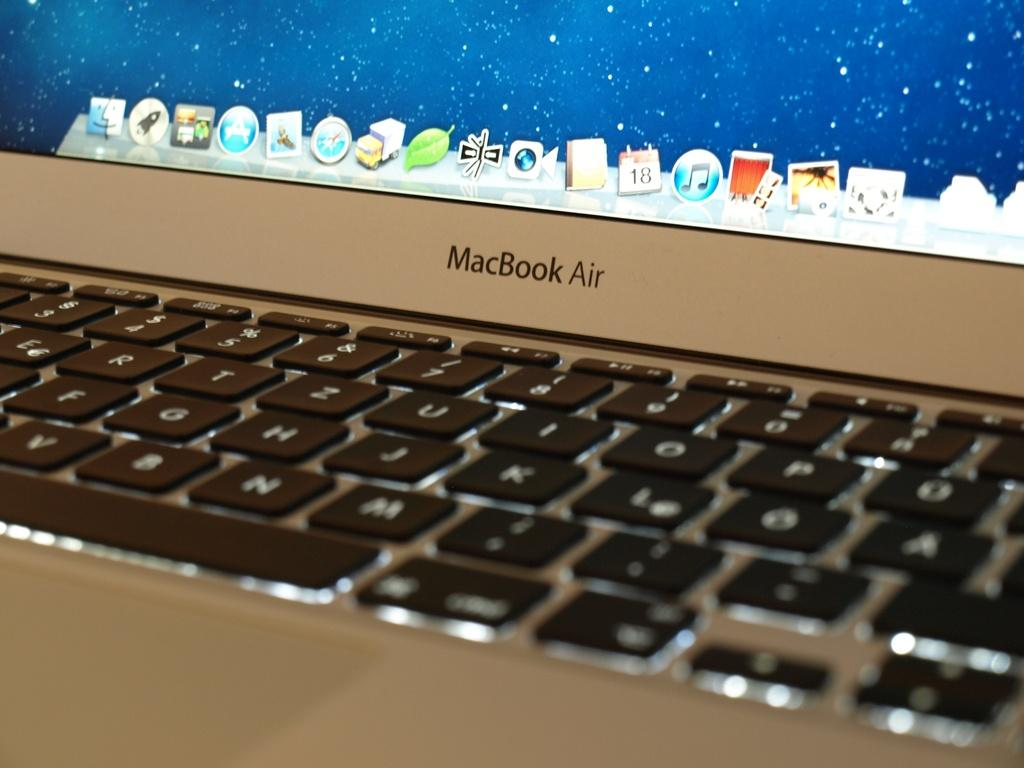What type of device is visible in the image? There is a keyboard in the image. What is the purpose of the keyboard? The keyboard is used for inputting data or commands into a computer or other electronic device. What else can be seen in the image besides the keyboard? There is a monitor screen in the image. What is the primary function of the monitor screen? The monitor screen is used for displaying information, images, or videos from a computer or other electronic device. What type of frame is holding the plate in the image? There is no frame or plate present in the image; it only features a keyboard and monitor screen. 